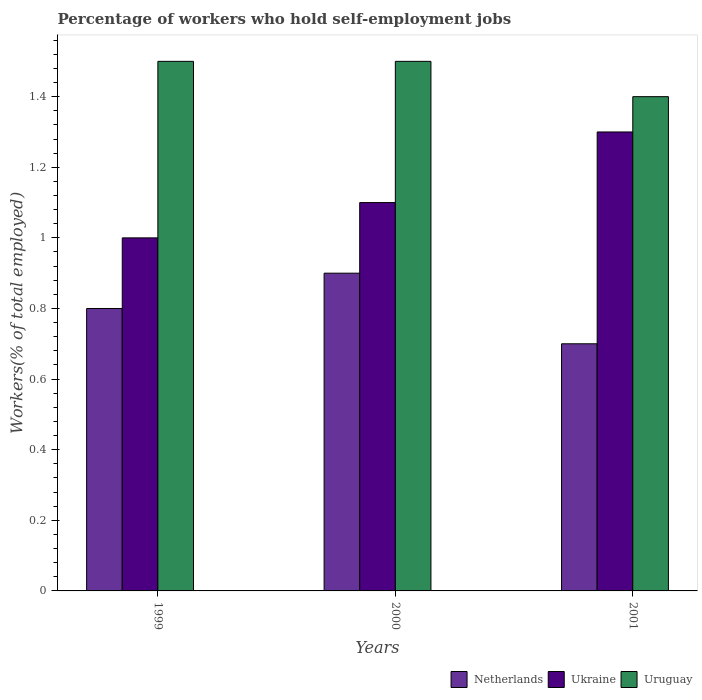How many different coloured bars are there?
Make the answer very short. 3. Are the number of bars per tick equal to the number of legend labels?
Your answer should be compact. Yes. Are the number of bars on each tick of the X-axis equal?
Offer a very short reply. Yes. How many bars are there on the 1st tick from the right?
Provide a succinct answer. 3. What is the label of the 3rd group of bars from the left?
Provide a short and direct response. 2001. What is the percentage of self-employed workers in Netherlands in 2000?
Ensure brevity in your answer.  0.9. Across all years, what is the maximum percentage of self-employed workers in Ukraine?
Offer a very short reply. 1.3. Across all years, what is the minimum percentage of self-employed workers in Uruguay?
Your answer should be compact. 1.4. What is the total percentage of self-employed workers in Netherlands in the graph?
Give a very brief answer. 2.4. What is the difference between the percentage of self-employed workers in Ukraine in 2000 and that in 2001?
Your answer should be very brief. -0.2. What is the difference between the percentage of self-employed workers in Ukraine in 2001 and the percentage of self-employed workers in Uruguay in 1999?
Your answer should be compact. -0.2. What is the average percentage of self-employed workers in Ukraine per year?
Keep it short and to the point. 1.13. In the year 2000, what is the difference between the percentage of self-employed workers in Ukraine and percentage of self-employed workers in Netherlands?
Your response must be concise. 0.2. What is the ratio of the percentage of self-employed workers in Netherlands in 1999 to that in 2001?
Make the answer very short. 1.14. What is the difference between the highest and the lowest percentage of self-employed workers in Ukraine?
Your answer should be very brief. 0.3. In how many years, is the percentage of self-employed workers in Ukraine greater than the average percentage of self-employed workers in Ukraine taken over all years?
Keep it short and to the point. 1. What does the 3rd bar from the left in 2001 represents?
Your answer should be compact. Uruguay. How many bars are there?
Make the answer very short. 9. What is the difference between two consecutive major ticks on the Y-axis?
Your response must be concise. 0.2. Are the values on the major ticks of Y-axis written in scientific E-notation?
Ensure brevity in your answer.  No. Does the graph contain any zero values?
Ensure brevity in your answer.  No. Does the graph contain grids?
Your answer should be compact. No. Where does the legend appear in the graph?
Keep it short and to the point. Bottom right. How are the legend labels stacked?
Give a very brief answer. Horizontal. What is the title of the graph?
Offer a very short reply. Percentage of workers who hold self-employment jobs. Does "Fiji" appear as one of the legend labels in the graph?
Offer a terse response. No. What is the label or title of the X-axis?
Offer a terse response. Years. What is the label or title of the Y-axis?
Your response must be concise. Workers(% of total employed). What is the Workers(% of total employed) of Netherlands in 1999?
Keep it short and to the point. 0.8. What is the Workers(% of total employed) in Ukraine in 1999?
Provide a short and direct response. 1. What is the Workers(% of total employed) in Netherlands in 2000?
Provide a succinct answer. 0.9. What is the Workers(% of total employed) of Ukraine in 2000?
Provide a succinct answer. 1.1. What is the Workers(% of total employed) of Uruguay in 2000?
Offer a very short reply. 1.5. What is the Workers(% of total employed) of Netherlands in 2001?
Offer a very short reply. 0.7. What is the Workers(% of total employed) in Ukraine in 2001?
Ensure brevity in your answer.  1.3. What is the Workers(% of total employed) in Uruguay in 2001?
Offer a terse response. 1.4. Across all years, what is the maximum Workers(% of total employed) in Netherlands?
Your answer should be very brief. 0.9. Across all years, what is the maximum Workers(% of total employed) in Ukraine?
Offer a terse response. 1.3. Across all years, what is the minimum Workers(% of total employed) of Netherlands?
Offer a very short reply. 0.7. Across all years, what is the minimum Workers(% of total employed) in Ukraine?
Offer a terse response. 1. Across all years, what is the minimum Workers(% of total employed) of Uruguay?
Provide a succinct answer. 1.4. What is the total Workers(% of total employed) of Netherlands in the graph?
Your answer should be compact. 2.4. What is the total Workers(% of total employed) in Uruguay in the graph?
Ensure brevity in your answer.  4.4. What is the difference between the Workers(% of total employed) in Netherlands in 1999 and that in 2000?
Ensure brevity in your answer.  -0.1. What is the difference between the Workers(% of total employed) of Uruguay in 1999 and that in 2000?
Give a very brief answer. 0. What is the difference between the Workers(% of total employed) of Netherlands in 1999 and that in 2001?
Give a very brief answer. 0.1. What is the difference between the Workers(% of total employed) of Netherlands in 1999 and the Workers(% of total employed) of Ukraine in 2000?
Give a very brief answer. -0.3. What is the difference between the Workers(% of total employed) in Netherlands in 1999 and the Workers(% of total employed) in Ukraine in 2001?
Keep it short and to the point. -0.5. What is the difference between the Workers(% of total employed) of Netherlands in 2000 and the Workers(% of total employed) of Ukraine in 2001?
Offer a terse response. -0.4. What is the difference between the Workers(% of total employed) of Netherlands in 2000 and the Workers(% of total employed) of Uruguay in 2001?
Provide a short and direct response. -0.5. What is the average Workers(% of total employed) in Netherlands per year?
Provide a short and direct response. 0.8. What is the average Workers(% of total employed) of Ukraine per year?
Your response must be concise. 1.13. What is the average Workers(% of total employed) in Uruguay per year?
Give a very brief answer. 1.47. In the year 2000, what is the difference between the Workers(% of total employed) of Netherlands and Workers(% of total employed) of Ukraine?
Ensure brevity in your answer.  -0.2. In the year 2000, what is the difference between the Workers(% of total employed) of Ukraine and Workers(% of total employed) of Uruguay?
Offer a terse response. -0.4. In the year 2001, what is the difference between the Workers(% of total employed) in Netherlands and Workers(% of total employed) in Ukraine?
Your answer should be compact. -0.6. In the year 2001, what is the difference between the Workers(% of total employed) in Netherlands and Workers(% of total employed) in Uruguay?
Ensure brevity in your answer.  -0.7. In the year 2001, what is the difference between the Workers(% of total employed) in Ukraine and Workers(% of total employed) in Uruguay?
Give a very brief answer. -0.1. What is the ratio of the Workers(% of total employed) in Ukraine in 1999 to that in 2000?
Keep it short and to the point. 0.91. What is the ratio of the Workers(% of total employed) of Netherlands in 1999 to that in 2001?
Ensure brevity in your answer.  1.14. What is the ratio of the Workers(% of total employed) of Ukraine in 1999 to that in 2001?
Provide a short and direct response. 0.77. What is the ratio of the Workers(% of total employed) in Uruguay in 1999 to that in 2001?
Provide a short and direct response. 1.07. What is the ratio of the Workers(% of total employed) of Ukraine in 2000 to that in 2001?
Keep it short and to the point. 0.85. What is the ratio of the Workers(% of total employed) of Uruguay in 2000 to that in 2001?
Provide a short and direct response. 1.07. What is the difference between the highest and the second highest Workers(% of total employed) in Ukraine?
Provide a short and direct response. 0.2. What is the difference between the highest and the lowest Workers(% of total employed) of Netherlands?
Provide a short and direct response. 0.2. What is the difference between the highest and the lowest Workers(% of total employed) of Ukraine?
Give a very brief answer. 0.3. What is the difference between the highest and the lowest Workers(% of total employed) in Uruguay?
Your answer should be very brief. 0.1. 